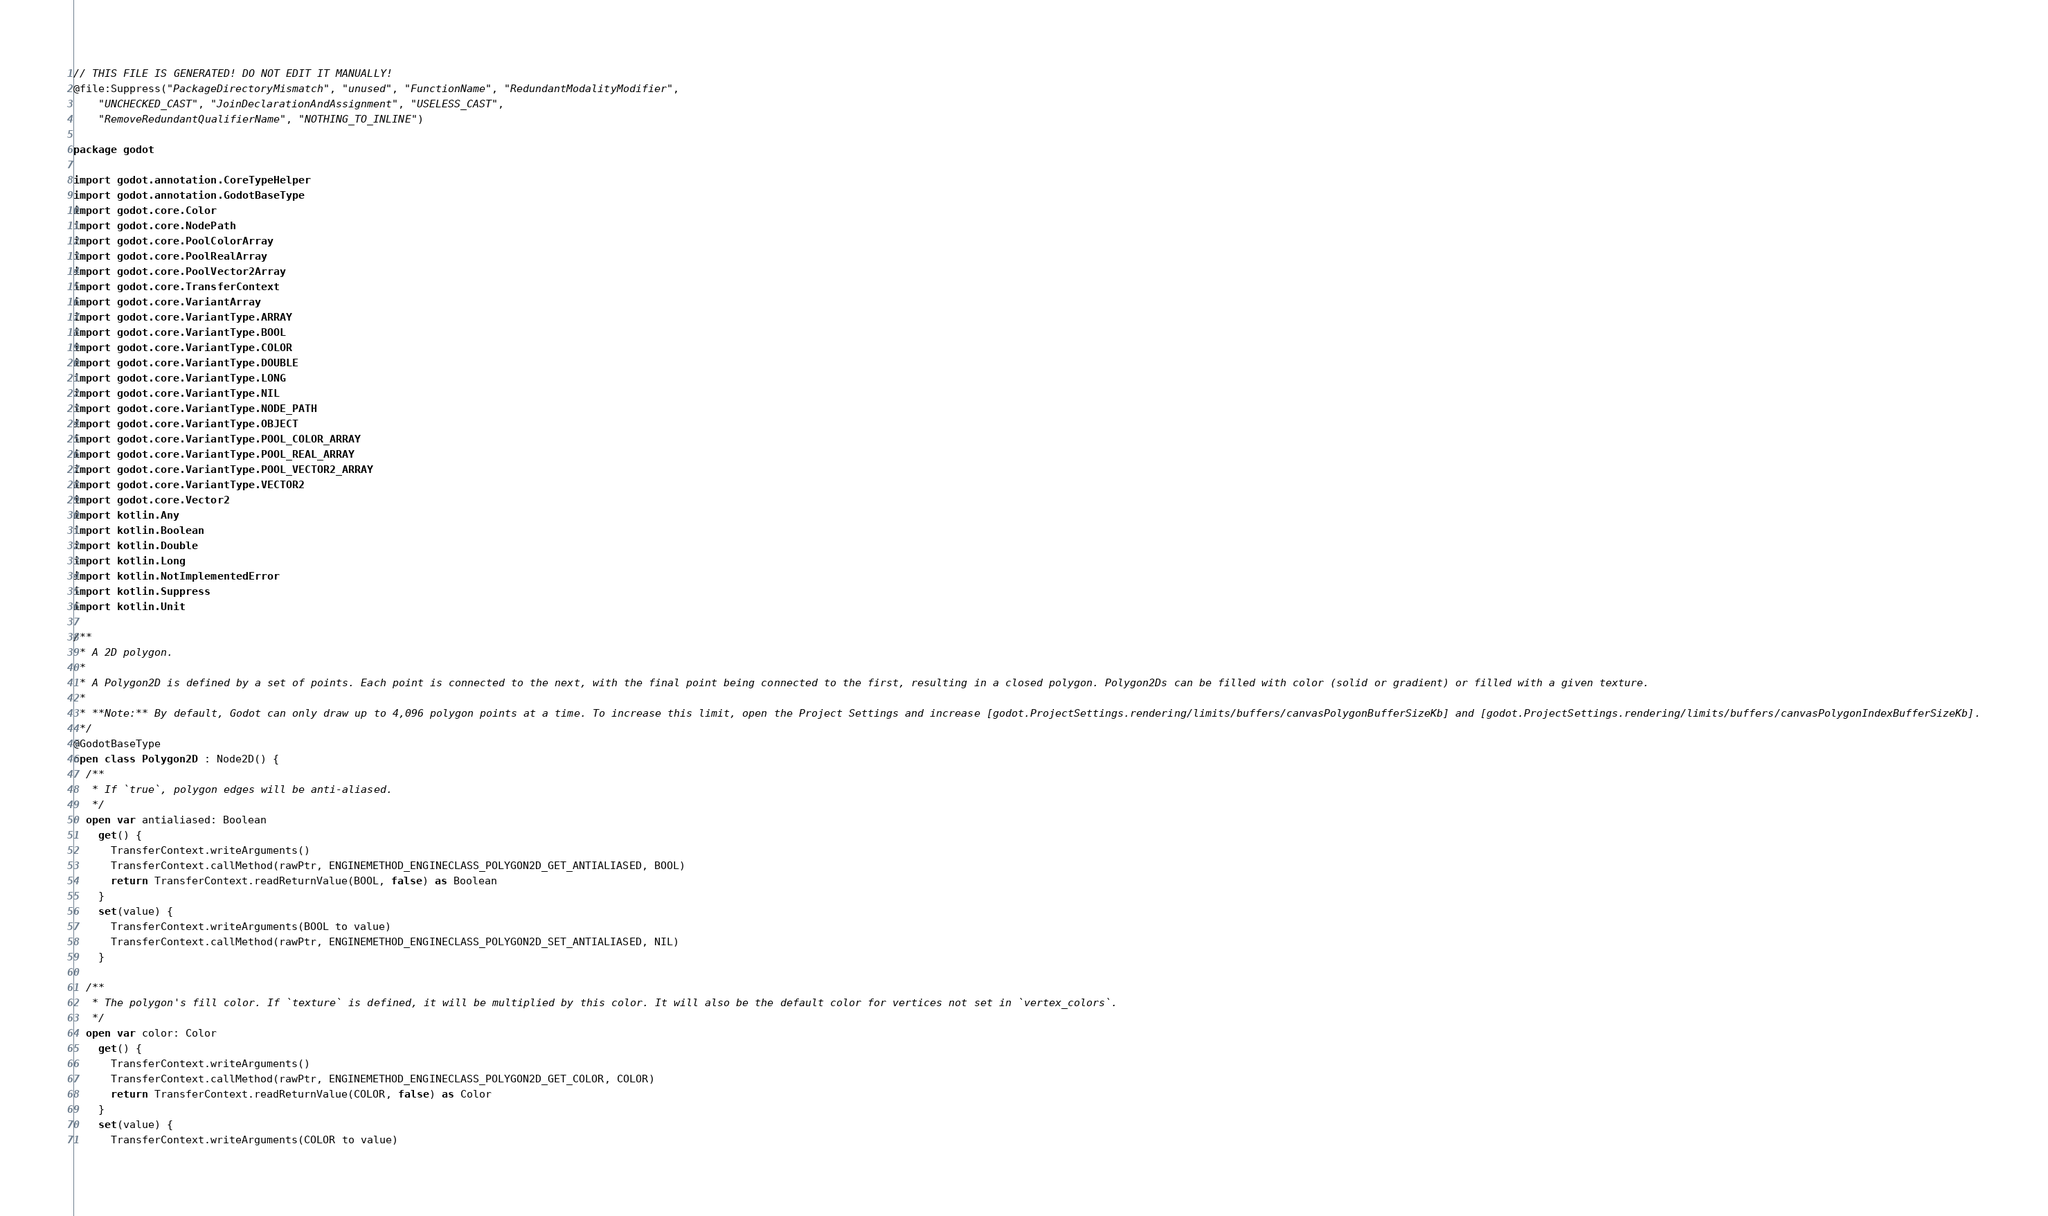Convert code to text. <code><loc_0><loc_0><loc_500><loc_500><_Kotlin_>// THIS FILE IS GENERATED! DO NOT EDIT IT MANUALLY!
@file:Suppress("PackageDirectoryMismatch", "unused", "FunctionName", "RedundantModalityModifier",
    "UNCHECKED_CAST", "JoinDeclarationAndAssignment", "USELESS_CAST",
    "RemoveRedundantQualifierName", "NOTHING_TO_INLINE")

package godot

import godot.annotation.CoreTypeHelper
import godot.annotation.GodotBaseType
import godot.core.Color
import godot.core.NodePath
import godot.core.PoolColorArray
import godot.core.PoolRealArray
import godot.core.PoolVector2Array
import godot.core.TransferContext
import godot.core.VariantArray
import godot.core.VariantType.ARRAY
import godot.core.VariantType.BOOL
import godot.core.VariantType.COLOR
import godot.core.VariantType.DOUBLE
import godot.core.VariantType.LONG
import godot.core.VariantType.NIL
import godot.core.VariantType.NODE_PATH
import godot.core.VariantType.OBJECT
import godot.core.VariantType.POOL_COLOR_ARRAY
import godot.core.VariantType.POOL_REAL_ARRAY
import godot.core.VariantType.POOL_VECTOR2_ARRAY
import godot.core.VariantType.VECTOR2
import godot.core.Vector2
import kotlin.Any
import kotlin.Boolean
import kotlin.Double
import kotlin.Long
import kotlin.NotImplementedError
import kotlin.Suppress
import kotlin.Unit

/**
 * A 2D polygon.
 *
 * A Polygon2D is defined by a set of points. Each point is connected to the next, with the final point being connected to the first, resulting in a closed polygon. Polygon2Ds can be filled with color (solid or gradient) or filled with a given texture.
 *
 * **Note:** By default, Godot can only draw up to 4,096 polygon points at a time. To increase this limit, open the Project Settings and increase [godot.ProjectSettings.rendering/limits/buffers/canvasPolygonBufferSizeKb] and [godot.ProjectSettings.rendering/limits/buffers/canvasPolygonIndexBufferSizeKb].
 */
@GodotBaseType
open class Polygon2D : Node2D() {
  /**
   * If `true`, polygon edges will be anti-aliased.
   */
  open var antialiased: Boolean
    get() {
      TransferContext.writeArguments()
      TransferContext.callMethod(rawPtr, ENGINEMETHOD_ENGINECLASS_POLYGON2D_GET_ANTIALIASED, BOOL)
      return TransferContext.readReturnValue(BOOL, false) as Boolean
    }
    set(value) {
      TransferContext.writeArguments(BOOL to value)
      TransferContext.callMethod(rawPtr, ENGINEMETHOD_ENGINECLASS_POLYGON2D_SET_ANTIALIASED, NIL)
    }

  /**
   * The polygon's fill color. If `texture` is defined, it will be multiplied by this color. It will also be the default color for vertices not set in `vertex_colors`.
   */
  open var color: Color
    get() {
      TransferContext.writeArguments()
      TransferContext.callMethod(rawPtr, ENGINEMETHOD_ENGINECLASS_POLYGON2D_GET_COLOR, COLOR)
      return TransferContext.readReturnValue(COLOR, false) as Color
    }
    set(value) {
      TransferContext.writeArguments(COLOR to value)</code> 